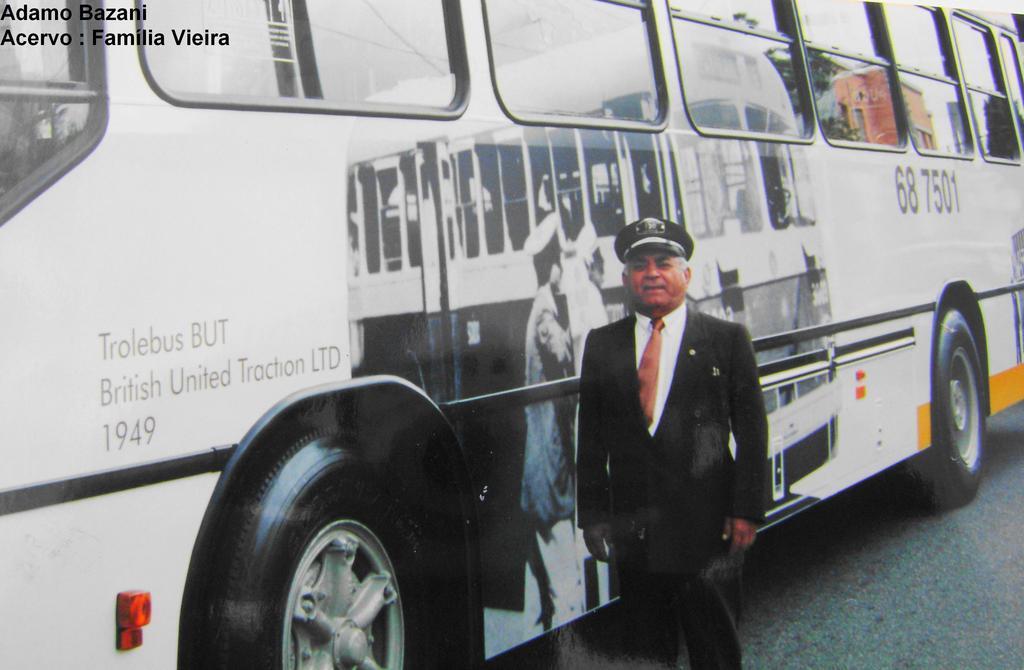How would you summarize this image in a sentence or two? In this image I can see the person standing and the person is wearing black blazer, white shirt and I can also see the vehicle in white and black color and I can see few glass windows. 